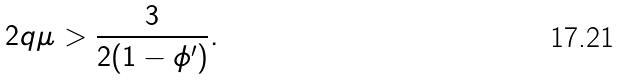Convert formula to latex. <formula><loc_0><loc_0><loc_500><loc_500>2 q \mu > \frac { 3 } { 2 ( 1 - \phi ^ { \prime } ) } .</formula> 